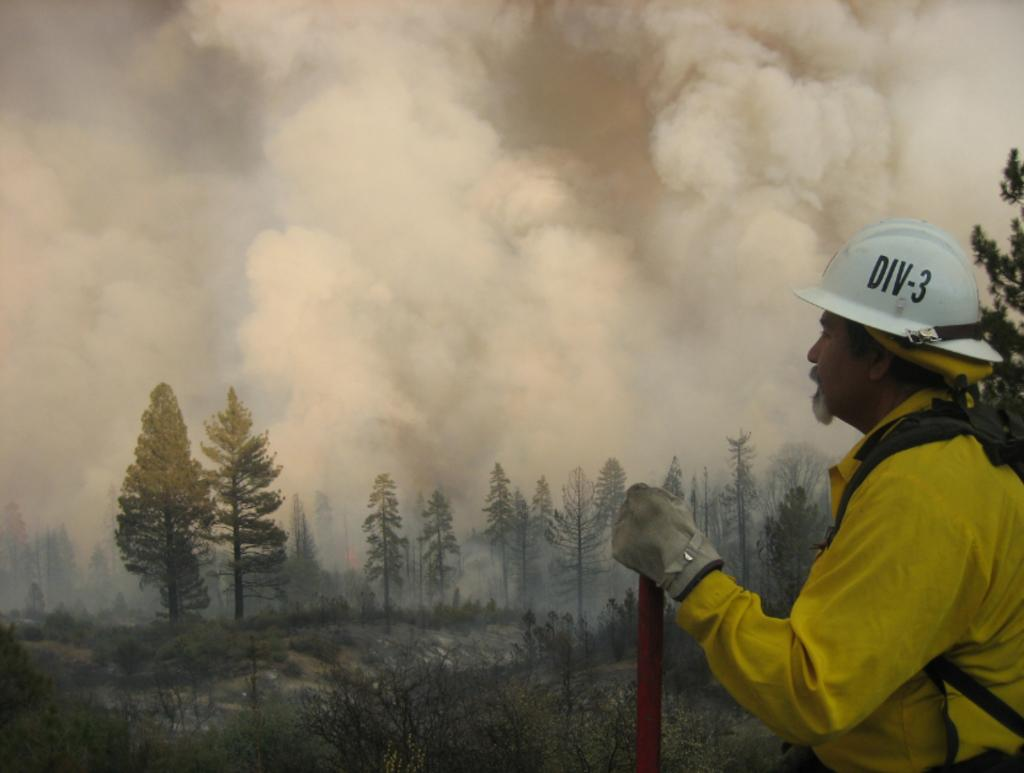What type of vegetation can be seen in the image? There are trees in the image. Where is the person located in the image? The person is on the right side of the image. What is the person wearing on their head? The person is wearing a helmet. What is the person holding in their hand? The person is holding a stick. What can be seen in the sky in the image? There is smoke in the sky. How does the person measure the distance between the trees in the image? There is no indication in the image that the person is measuring anything, and no measuring tools are visible. Can you see any animals from the zoo in the image? There is no mention of a zoo or any animals in the image. Is the person holding an umbrella in the image? No, the person is holding a stick, not an umbrella. 